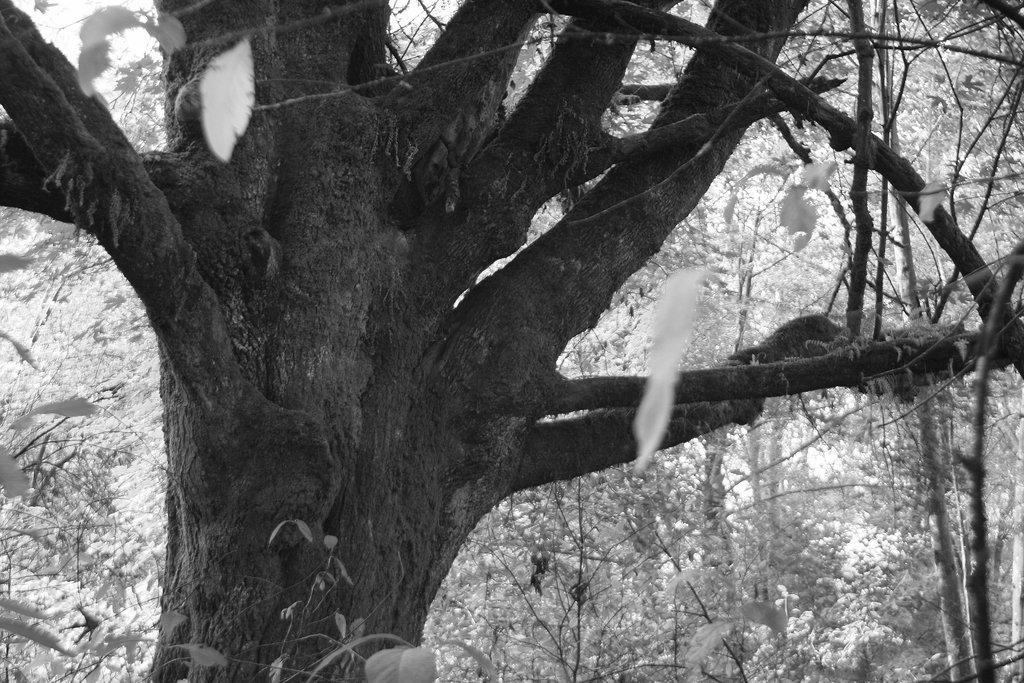Can you describe this image briefly? This is a black and white image. In the center of the image there is a tree trunk. In the background of the image there are trees. 